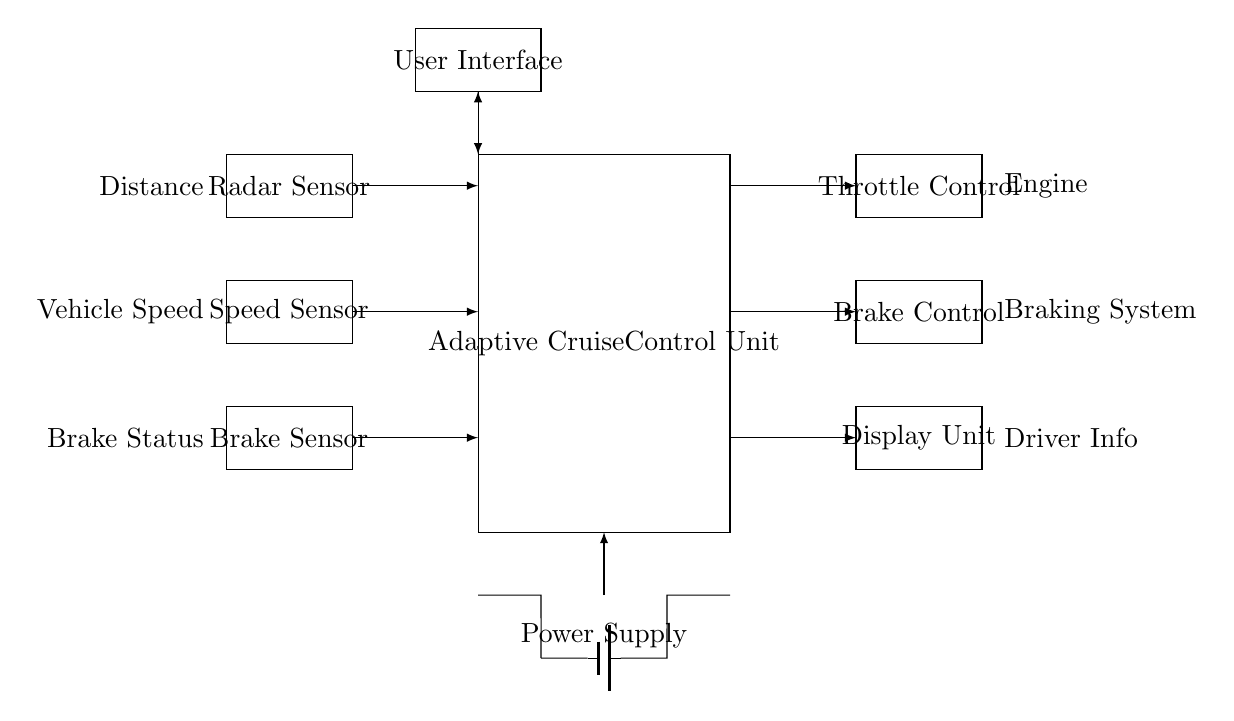what is the main component of this circuit? The main component is the Adaptive Cruise Control Unit, responsible for processing input from sensors and controlling the vehicle’s throttle and brakes.
Answer: Adaptive Cruise Control Unit how many sensors are present in the circuit? There are three sensors in the circuit: a radar sensor, a speed sensor, and a brake sensor. This is counted by identifying each rectangle labeled as a sensor in the top left section of the diagram.
Answer: Three where does the power supply connect in the circuit? The power supply connects to the Adaptive Cruise Control Unit, providing necessary voltage for operation. This is determined by tracing the connections from the power supply to the unit.
Answer: Adaptive Cruise Control Unit what is the purpose of the display unit? The display unit serves to inform the driver of various system statuses like speed and distance, helping maintain awareness while using adaptive cruise control. It is directly connected to the control unit, which implies its role in driver feedback.
Answer: Informing the driver what does the connection from the brake sensor to the control unit indicate? This connection indicates that the control unit receives input regarding the brake status, which is crucial for ensuring the vehicle can respond appropriately when brakes are applied. This reasoning is based on the necessity of feedback for safe operation.
Answer: Brake status feedback which actuator receives input from the adaptive cruise control unit? The throttle control and brake control actuators receive input from the adaptive cruise control unit to adjust the vehicle's speed and braking accordingly, showing the control unit's role in managing these actions.
Answer: Throttle Control and Brake Control 